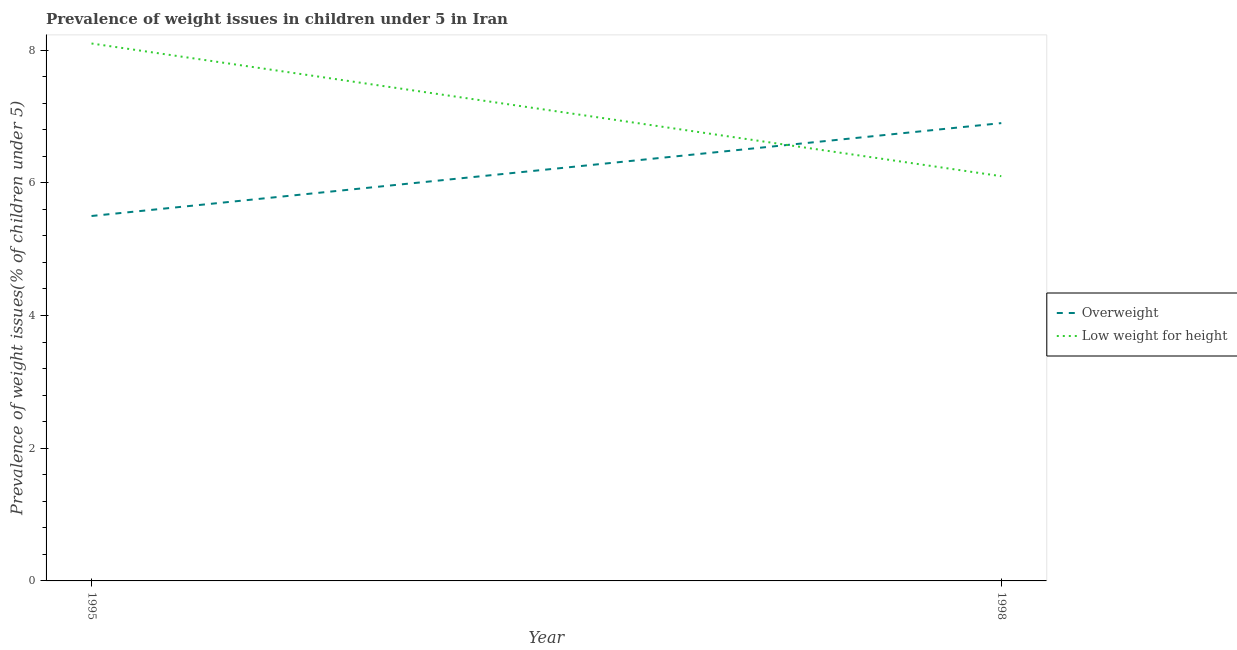Does the line corresponding to percentage of overweight children intersect with the line corresponding to percentage of underweight children?
Keep it short and to the point. Yes. Is the number of lines equal to the number of legend labels?
Offer a terse response. Yes. What is the percentage of overweight children in 1998?
Offer a very short reply. 6.9. Across all years, what is the maximum percentage of overweight children?
Offer a terse response. 6.9. Across all years, what is the minimum percentage of overweight children?
Your response must be concise. 5.5. In which year was the percentage of underweight children maximum?
Give a very brief answer. 1995. What is the total percentage of underweight children in the graph?
Make the answer very short. 14.2. What is the difference between the percentage of underweight children in 1995 and that in 1998?
Provide a succinct answer. 2. What is the difference between the percentage of overweight children in 1998 and the percentage of underweight children in 1995?
Give a very brief answer. -1.2. What is the average percentage of overweight children per year?
Your answer should be very brief. 6.2. In the year 1995, what is the difference between the percentage of overweight children and percentage of underweight children?
Ensure brevity in your answer.  -2.6. In how many years, is the percentage of underweight children greater than 7.2 %?
Give a very brief answer. 1. What is the ratio of the percentage of underweight children in 1995 to that in 1998?
Your answer should be very brief. 1.33. Is the percentage of overweight children strictly less than the percentage of underweight children over the years?
Your response must be concise. No. How many lines are there?
Ensure brevity in your answer.  2. How many years are there in the graph?
Keep it short and to the point. 2. Where does the legend appear in the graph?
Provide a short and direct response. Center right. How many legend labels are there?
Your response must be concise. 2. What is the title of the graph?
Offer a very short reply. Prevalence of weight issues in children under 5 in Iran. What is the label or title of the Y-axis?
Provide a short and direct response. Prevalence of weight issues(% of children under 5). What is the Prevalence of weight issues(% of children under 5) of Overweight in 1995?
Your response must be concise. 5.5. What is the Prevalence of weight issues(% of children under 5) in Low weight for height in 1995?
Give a very brief answer. 8.1. What is the Prevalence of weight issues(% of children under 5) of Overweight in 1998?
Make the answer very short. 6.9. What is the Prevalence of weight issues(% of children under 5) in Low weight for height in 1998?
Provide a succinct answer. 6.1. Across all years, what is the maximum Prevalence of weight issues(% of children under 5) of Overweight?
Your answer should be compact. 6.9. Across all years, what is the maximum Prevalence of weight issues(% of children under 5) of Low weight for height?
Offer a terse response. 8.1. Across all years, what is the minimum Prevalence of weight issues(% of children under 5) of Low weight for height?
Your response must be concise. 6.1. What is the total Prevalence of weight issues(% of children under 5) in Overweight in the graph?
Your response must be concise. 12.4. What is the total Prevalence of weight issues(% of children under 5) of Low weight for height in the graph?
Provide a short and direct response. 14.2. What is the difference between the Prevalence of weight issues(% of children under 5) of Overweight in 1995 and that in 1998?
Your answer should be very brief. -1.4. What is the average Prevalence of weight issues(% of children under 5) of Overweight per year?
Ensure brevity in your answer.  6.2. What is the average Prevalence of weight issues(% of children under 5) of Low weight for height per year?
Ensure brevity in your answer.  7.1. In the year 1995, what is the difference between the Prevalence of weight issues(% of children under 5) of Overweight and Prevalence of weight issues(% of children under 5) of Low weight for height?
Make the answer very short. -2.6. What is the ratio of the Prevalence of weight issues(% of children under 5) of Overweight in 1995 to that in 1998?
Your answer should be very brief. 0.8. What is the ratio of the Prevalence of weight issues(% of children under 5) in Low weight for height in 1995 to that in 1998?
Offer a very short reply. 1.33. What is the difference between the highest and the second highest Prevalence of weight issues(% of children under 5) of Overweight?
Keep it short and to the point. 1.4. What is the difference between the highest and the second highest Prevalence of weight issues(% of children under 5) of Low weight for height?
Offer a very short reply. 2. 